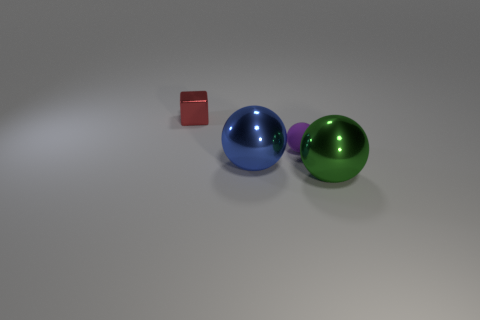Can you describe the materials that the spheres and the cube seem to be made of? The spheres and the cube appear to have a reflective surface, suggesting they might be made of materials like polished metal or plastic, common in computer-generated imagery for showcasing reflectivity and shine. What does the shadowing tell us about the light source in this scene? The shadowing in this scene indicates a diffused overhead light source, causing soft-edged shadows directly underneath the objects. This suggests the light source is not too close to the objects, allowing for a more even distribution of light. 